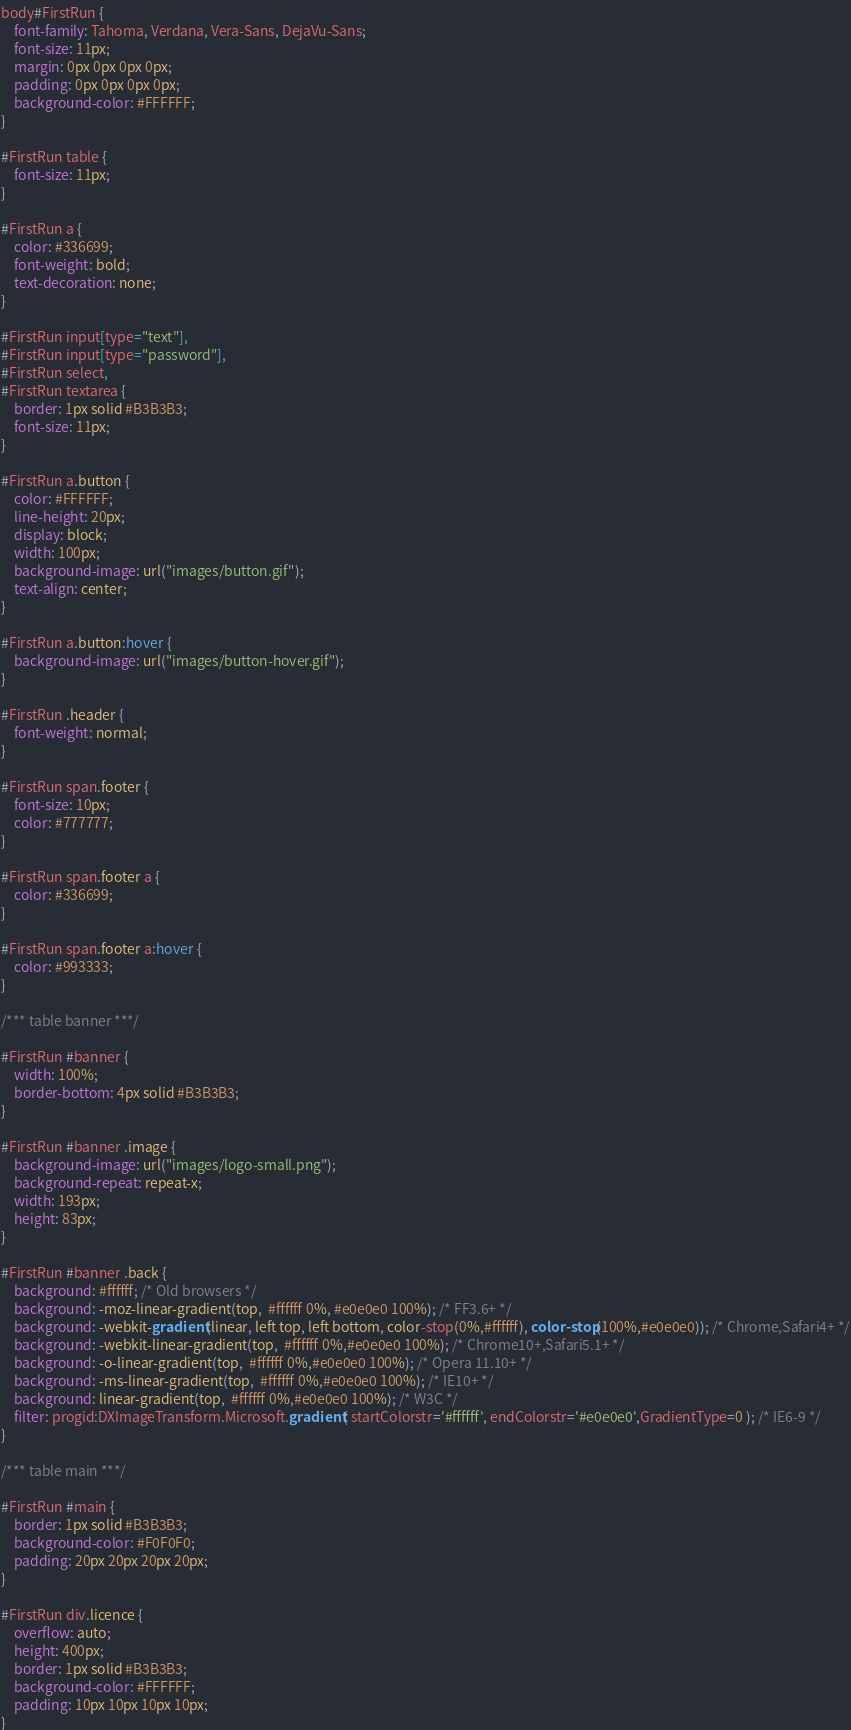<code> <loc_0><loc_0><loc_500><loc_500><_CSS_>body#FirstRun {
    font-family: Tahoma, Verdana, Vera-Sans, DejaVu-Sans;
    font-size: 11px;
    margin: 0px 0px 0px 0px;
    padding: 0px 0px 0px 0px;
    background-color: #FFFFFF;
}

#FirstRun table {
    font-size: 11px;
}

#FirstRun a {
    color: #336699;
    font-weight: bold;
    text-decoration: none;
}

#FirstRun input[type="text"],
#FirstRun input[type="password"],
#FirstRun select,
#FirstRun textarea {
    border: 1px solid #B3B3B3;
    font-size: 11px;
}

#FirstRun a.button {
    color: #FFFFFF;
    line-height: 20px;
    display: block;
    width: 100px;
    background-image: url("images/button.gif");
    text-align: center;
}

#FirstRun a.button:hover {
    background-image: url("images/button-hover.gif");
}

#FirstRun .header {
    font-weight: normal;
}

#FirstRun span.footer {
    font-size: 10px;
    color: #777777;
}

#FirstRun span.footer a {
    color: #336699;
}

#FirstRun span.footer a:hover {
    color: #993333;
}

/*** table banner ***/

#FirstRun #banner {
    width: 100%;
    border-bottom: 4px solid #B3B3B3;
}

#FirstRun #banner .image {
    background-image: url("images/logo-small.png");
    background-repeat: repeat-x;
    width: 193px;
    height: 83px;
}

#FirstRun #banner .back {
	background: #ffffff; /* Old browsers */
	background: -moz-linear-gradient(top,  #ffffff 0%, #e0e0e0 100%); /* FF3.6+ */
	background: -webkit-gradient(linear, left top, left bottom, color-stop(0%,#ffffff), color-stop(100%,#e0e0e0)); /* Chrome,Safari4+ */
	background: -webkit-linear-gradient(top,  #ffffff 0%,#e0e0e0 100%); /* Chrome10+,Safari5.1+ */
	background: -o-linear-gradient(top,  #ffffff 0%,#e0e0e0 100%); /* Opera 11.10+ */
	background: -ms-linear-gradient(top,  #ffffff 0%,#e0e0e0 100%); /* IE10+ */
	background: linear-gradient(top,  #ffffff 0%,#e0e0e0 100%); /* W3C */
	filter: progid:DXImageTransform.Microsoft.gradient( startColorstr='#ffffff', endColorstr='#e0e0e0',GradientType=0 ); /* IE6-9 */
}

/*** table main ***/

#FirstRun #main {
    border: 1px solid #B3B3B3;
    background-color: #F0F0F0;
    padding: 20px 20px 20px 20px;
}

#FirstRun div.licence {
    overflow: auto;
    height: 400px;
    border: 1px solid #B3B3B3;
    background-color: #FFFFFF;
    padding: 10px 10px 10px 10px;
}
</code> 